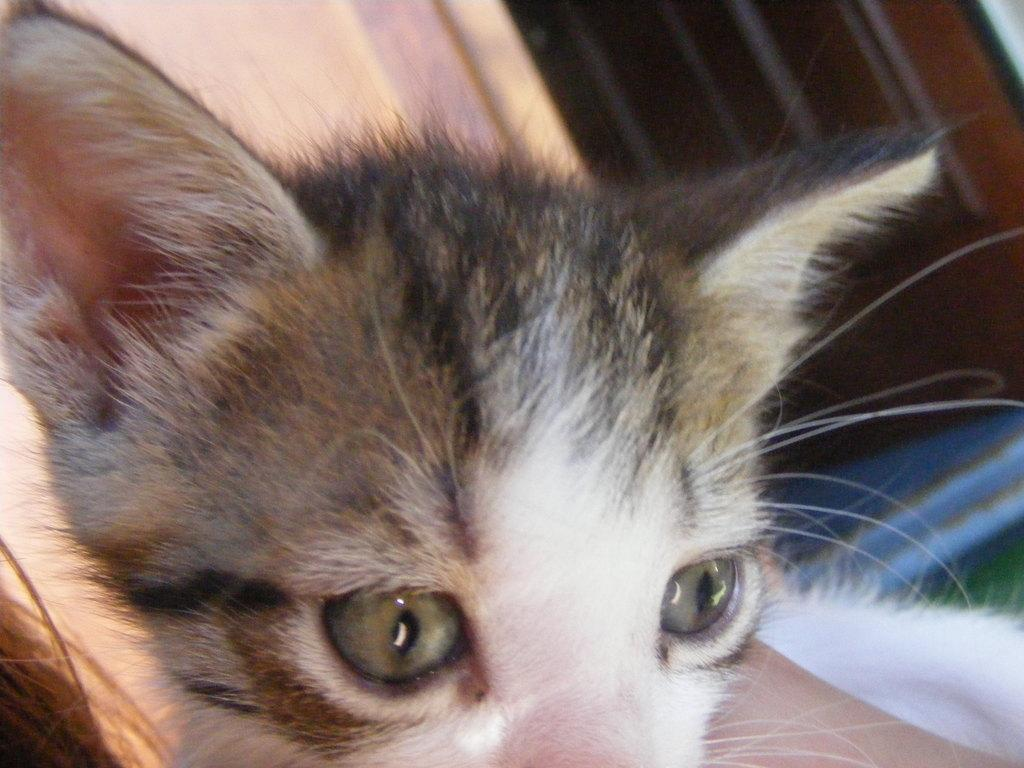What is the main subject of the image? The main subject of the image is a cat's face. Can you describe the colors of the cat's face? The cat's face has brown and white colors. Can you tell me how many keys are attached to the cat's chin in the image? There are no keys present in the image, and the cat's chin is not visible. 